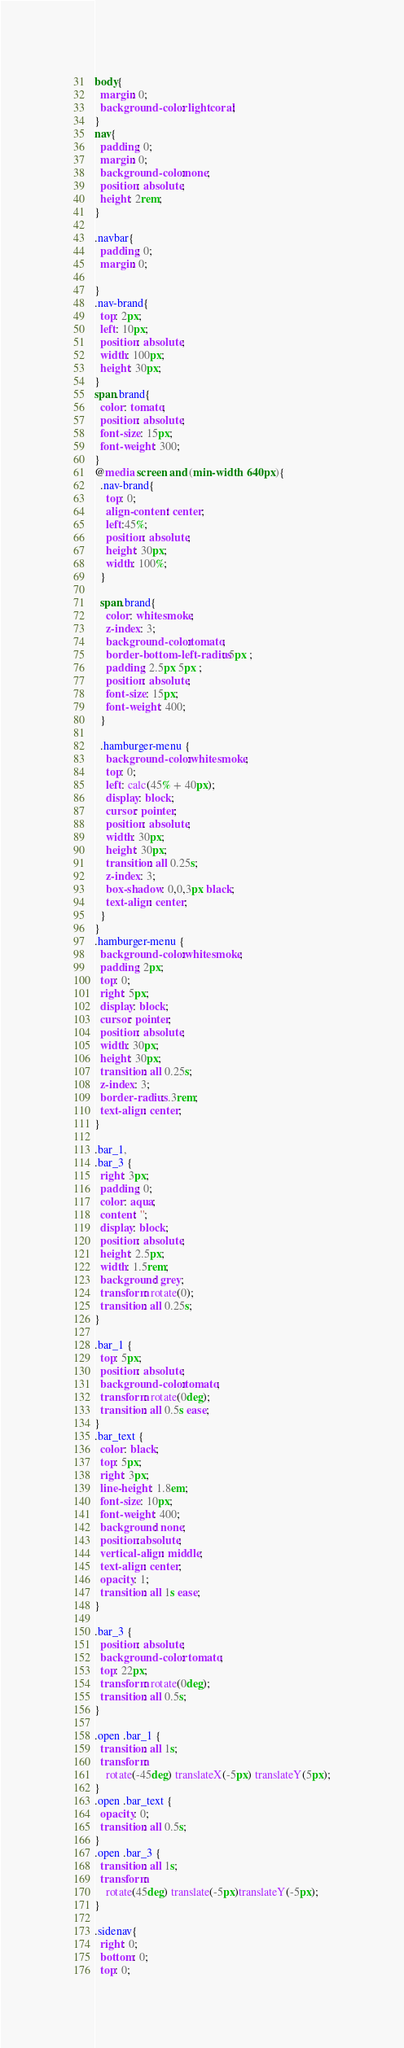<code> <loc_0><loc_0><loc_500><loc_500><_CSS_>body{
  margin: 0;
  background-color: lightcoral;
}
nav{
  padding: 0;
  margin: 0;
  background-color:none;
  position: absolute;
  height: 2rem;
}

.navbar{
  padding: 0;
  margin: 0;

}
.nav-brand{
  top: 2px;
  left: 10px;
  position: absolute;
  width: 100px;
  height: 30px;
}
span.brand{
  color: tomato;
  position: absolute;
  font-size: 15px;
  font-weight: 300;
}
@media screen and (min-width: 640px){
  .nav-brand{
    top: 0;
    align-content: center;
    left:45%;
    position: absolute;
    height: 30px;
    width: 100%;
  }

  span.brand{
    color: whitesmoke;
    z-index: 3;
    background-color:tomato;
    border-bottom-left-radius: 5px ;
    padding: 2.5px 5px ;
    position: absolute;
    font-size: 15px;
    font-weight: 400;
  }

  .hamburger-menu {
    background-color:whitesmoke;
    top: 0;
    left: calc(45% + 40px);
    display: block;
    cursor: pointer;
    position: absolute;
    width: 30px;
    height: 30px;
    transition: all 0.25s;
    z-index: 3;
    box-shadow: 0,0,3px black;
    text-align: center;
  }
}
.hamburger-menu {
  background-color:whitesmoke;
  padding: 2px;
  top: 0;
  right: 5px;
  display: block;
  cursor: pointer;
  position: absolute;
  width: 30px;
  height: 30px;
  transition: all 0.25s;
  z-index: 3;
  border-radius: .3rem;
  text-align: center;
}

.bar_1,
.bar_3 {
  right: 3px;
  padding: 0;
  color: aqua;
  content: '';
  display: block;
  position: absolute;
  height: 2.5px;
  width: 1.5rem;
  background: grey;
  transform: rotate(0);
  transition: all 0.25s;
}

.bar_1 {
  top: 5px;
  position: absolute;
  background-color:tomato;
  transform: rotate(0deg);
  transition: all 0.5s ease;
}
.bar_text {
  color: black;
  top: 5px;
  right: 3px;
  line-height: 1.8em;
  font-size: 10px;
  font-weight: 400;
  background: none;
  position:absolute;
  vertical-align: middle;
  text-align: center;
  opacity: 1;
  transition: all 1s ease;
}

.bar_3 {
  position: absolute;
  background-color: tomato;
  top: 22px;
  transform: rotate(0deg);
  transition: all 0.5s;
}

.open .bar_1 {
  transition: all 1s;
  transform: 
    rotate(-45deg) translateX(-5px) translateY(5px);
}
.open .bar_text {
  opacity: 0;
  transition: all 0.5s;
}
.open .bar_3 {
  transition: all 1s;
  transform: 
    rotate(45deg) translate(-5px)translateY(-5px);
} 

.sidenav{
  right: 0;
  bottom: 0;
  top: 0;</code> 